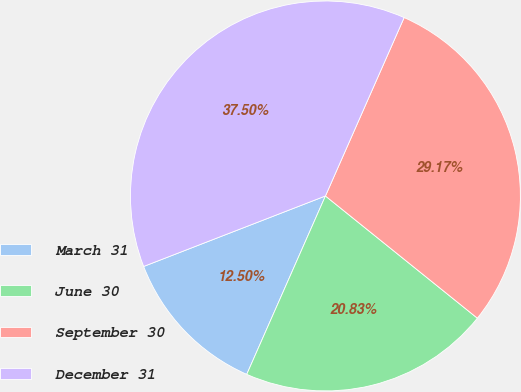Convert chart. <chart><loc_0><loc_0><loc_500><loc_500><pie_chart><fcel>March 31<fcel>June 30<fcel>September 30<fcel>December 31<nl><fcel>12.5%<fcel>20.83%<fcel>29.17%<fcel>37.5%<nl></chart> 